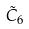<formula> <loc_0><loc_0><loc_500><loc_500>\tilde { C } _ { 6 }</formula> 